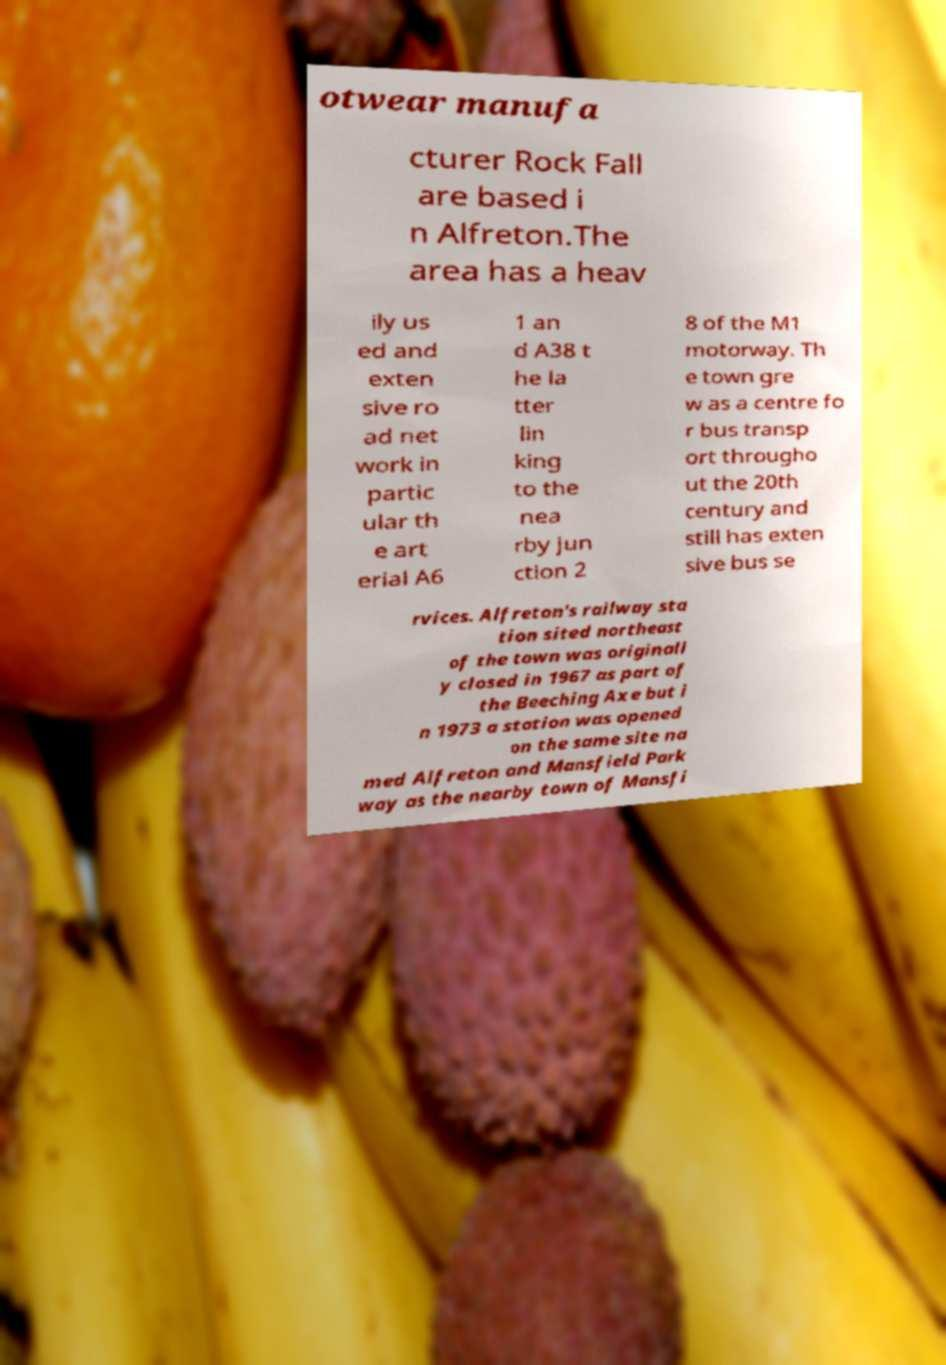Please identify and transcribe the text found in this image. otwear manufa cturer Rock Fall are based i n Alfreton.The area has a heav ily us ed and exten sive ro ad net work in partic ular th e art erial A6 1 an d A38 t he la tter lin king to the nea rby jun ction 2 8 of the M1 motorway. Th e town gre w as a centre fo r bus transp ort througho ut the 20th century and still has exten sive bus se rvices. Alfreton's railway sta tion sited northeast of the town was originall y closed in 1967 as part of the Beeching Axe but i n 1973 a station was opened on the same site na med Alfreton and Mansfield Park way as the nearby town of Mansfi 